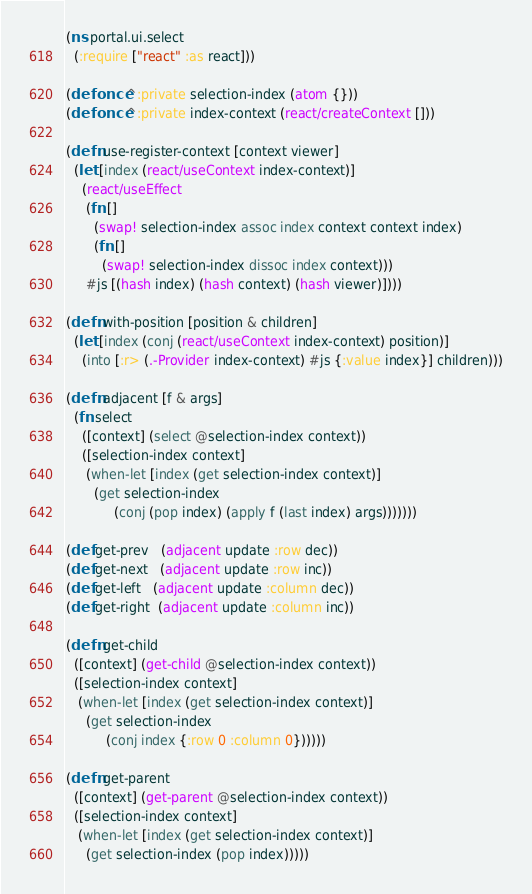Convert code to text. <code><loc_0><loc_0><loc_500><loc_500><_Clojure_>(ns portal.ui.select
  (:require ["react" :as react]))

(defonce ^:private selection-index (atom {}))
(defonce ^:private index-context (react/createContext []))

(defn use-register-context [context viewer]
  (let [index (react/useContext index-context)]
    (react/useEffect
     (fn []
       (swap! selection-index assoc index context context index)
       (fn []
         (swap! selection-index dissoc index context)))
     #js [(hash index) (hash context) (hash viewer)])))

(defn with-position [position & children]
  (let [index (conj (react/useContext index-context) position)]
    (into [:r> (.-Provider index-context) #js {:value index}] children)))

(defn adjacent [f & args]
  (fn select
    ([context] (select @selection-index context))
    ([selection-index context]
     (when-let [index (get selection-index context)]
       (get selection-index
            (conj (pop index) (apply f (last index) args)))))))

(def get-prev   (adjacent update :row dec))
(def get-next   (adjacent update :row inc))
(def get-left   (adjacent update :column dec))
(def get-right  (adjacent update :column inc))

(defn get-child
  ([context] (get-child @selection-index context))
  ([selection-index context]
   (when-let [index (get selection-index context)]
     (get selection-index
          (conj index {:row 0 :column 0})))))

(defn get-parent
  ([context] (get-parent @selection-index context))
  ([selection-index context]
   (when-let [index (get selection-index context)]
     (get selection-index (pop index)))))
</code> 